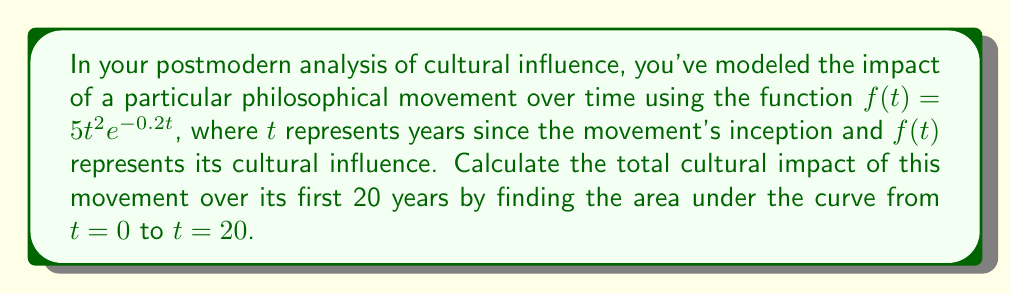Could you help me with this problem? To solve this problem, we need to calculate the definite integral of the given function from 0 to 20. Let's approach this step-by-step:

1) The function we need to integrate is $f(t) = 5t^2e^{-0.2t}$

2) We need to calculate $\int_0^{20} 5t^2e^{-0.2t} dt$

3) This integral doesn't have an elementary antiderivative, so we'll need to use integration by parts twice.

4) Let $u = t^2$ and $dv = e^{-0.2t}dt$

   Then $du = 2t dt$ and $v = -5e^{-0.2t}$

5) Using the integration by parts formula:

   $\int t^2e^{-0.2t} dt = -5t^2e^{-0.2t} - \int (-10te^{-0.2t}) dt$

6) For the remaining integral, let $u = t$ and $dv = e^{-0.2t}dt$

   Then $du = dt$ and $v = -5e^{-0.2t}$

7) Applying integration by parts again:

   $\int te^{-0.2t} dt = -5te^{-0.2t} - \int (-5e^{-0.2t}) dt$

8) The last integral is straightforward:

   $\int e^{-0.2t} dt = -5e^{-0.2t}$

9) Putting it all together:

   $\int t^2e^{-0.2t} dt = -5t^2e^{-0.2t} + 50te^{-0.2t} - 25e^{-0.2t} + C$

10) Now we can apply the limits:

    $\left[-5t^2e^{-0.2t} + 50te^{-0.2t} - 25e^{-0.2t}\right]_0^{20}$

11) Evaluating at $t=20$ and $t=0$:

    $(-5(20^2)e^{-4} + 50(20)e^{-4} - 25e^{-4}) - (-5(0^2)e^0 + 50(0)e^0 - 25e^0)$
    
    $= (-2000e^{-4} + 1000e^{-4} - 25e^{-4}) - (-25)$
    
    $= -1025e^{-4} + 25$

12) Finally, multiply the result by 5 (as per the original function):

    $5(-1025e^{-4} + 25) = -5125e^{-4} + 125$
Answer: The total cultural impact over the first 20 years is $-5125e^{-4} + 125 \approx 123.76$ units of cultural influence. 